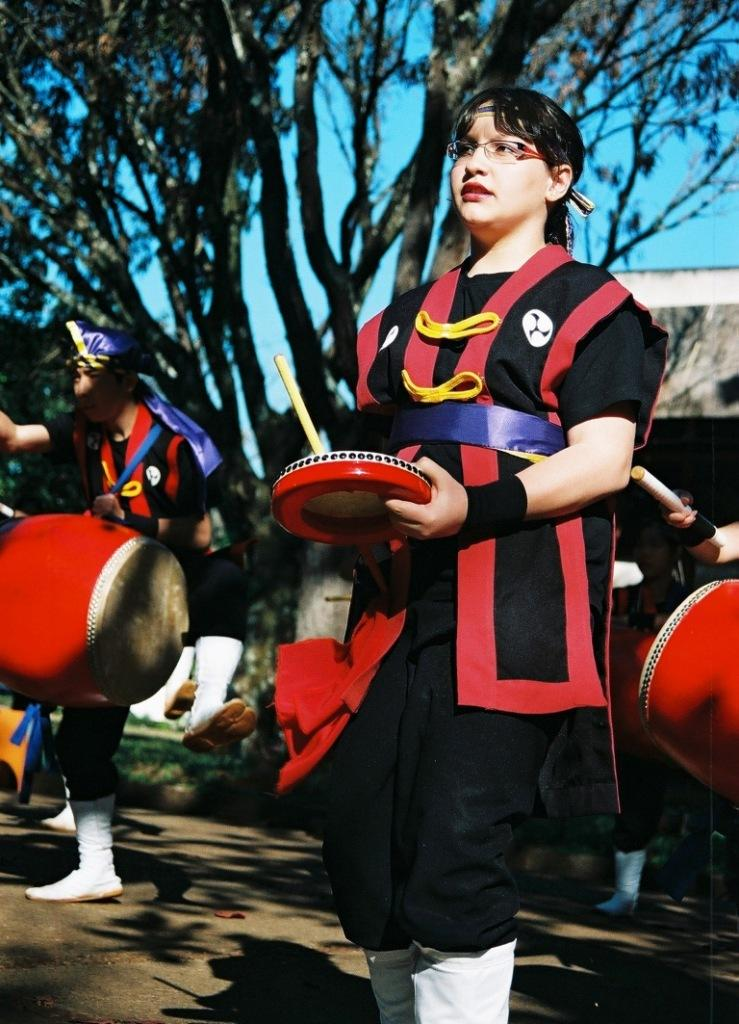What are the people in the image doing? The people in the image are playing musical instruments. What can be seen in the background of the image? There is a tree, a house, and the sky visible in the background of the image. What is at the bottom of the image? There is a road at the bottom of the image. What passenger is feeling ashamed in the image? There is no passenger present in the image, and therefore no one is feeling ashamed. How does the road move in the image? The road does not move in the image; it is stationary. 